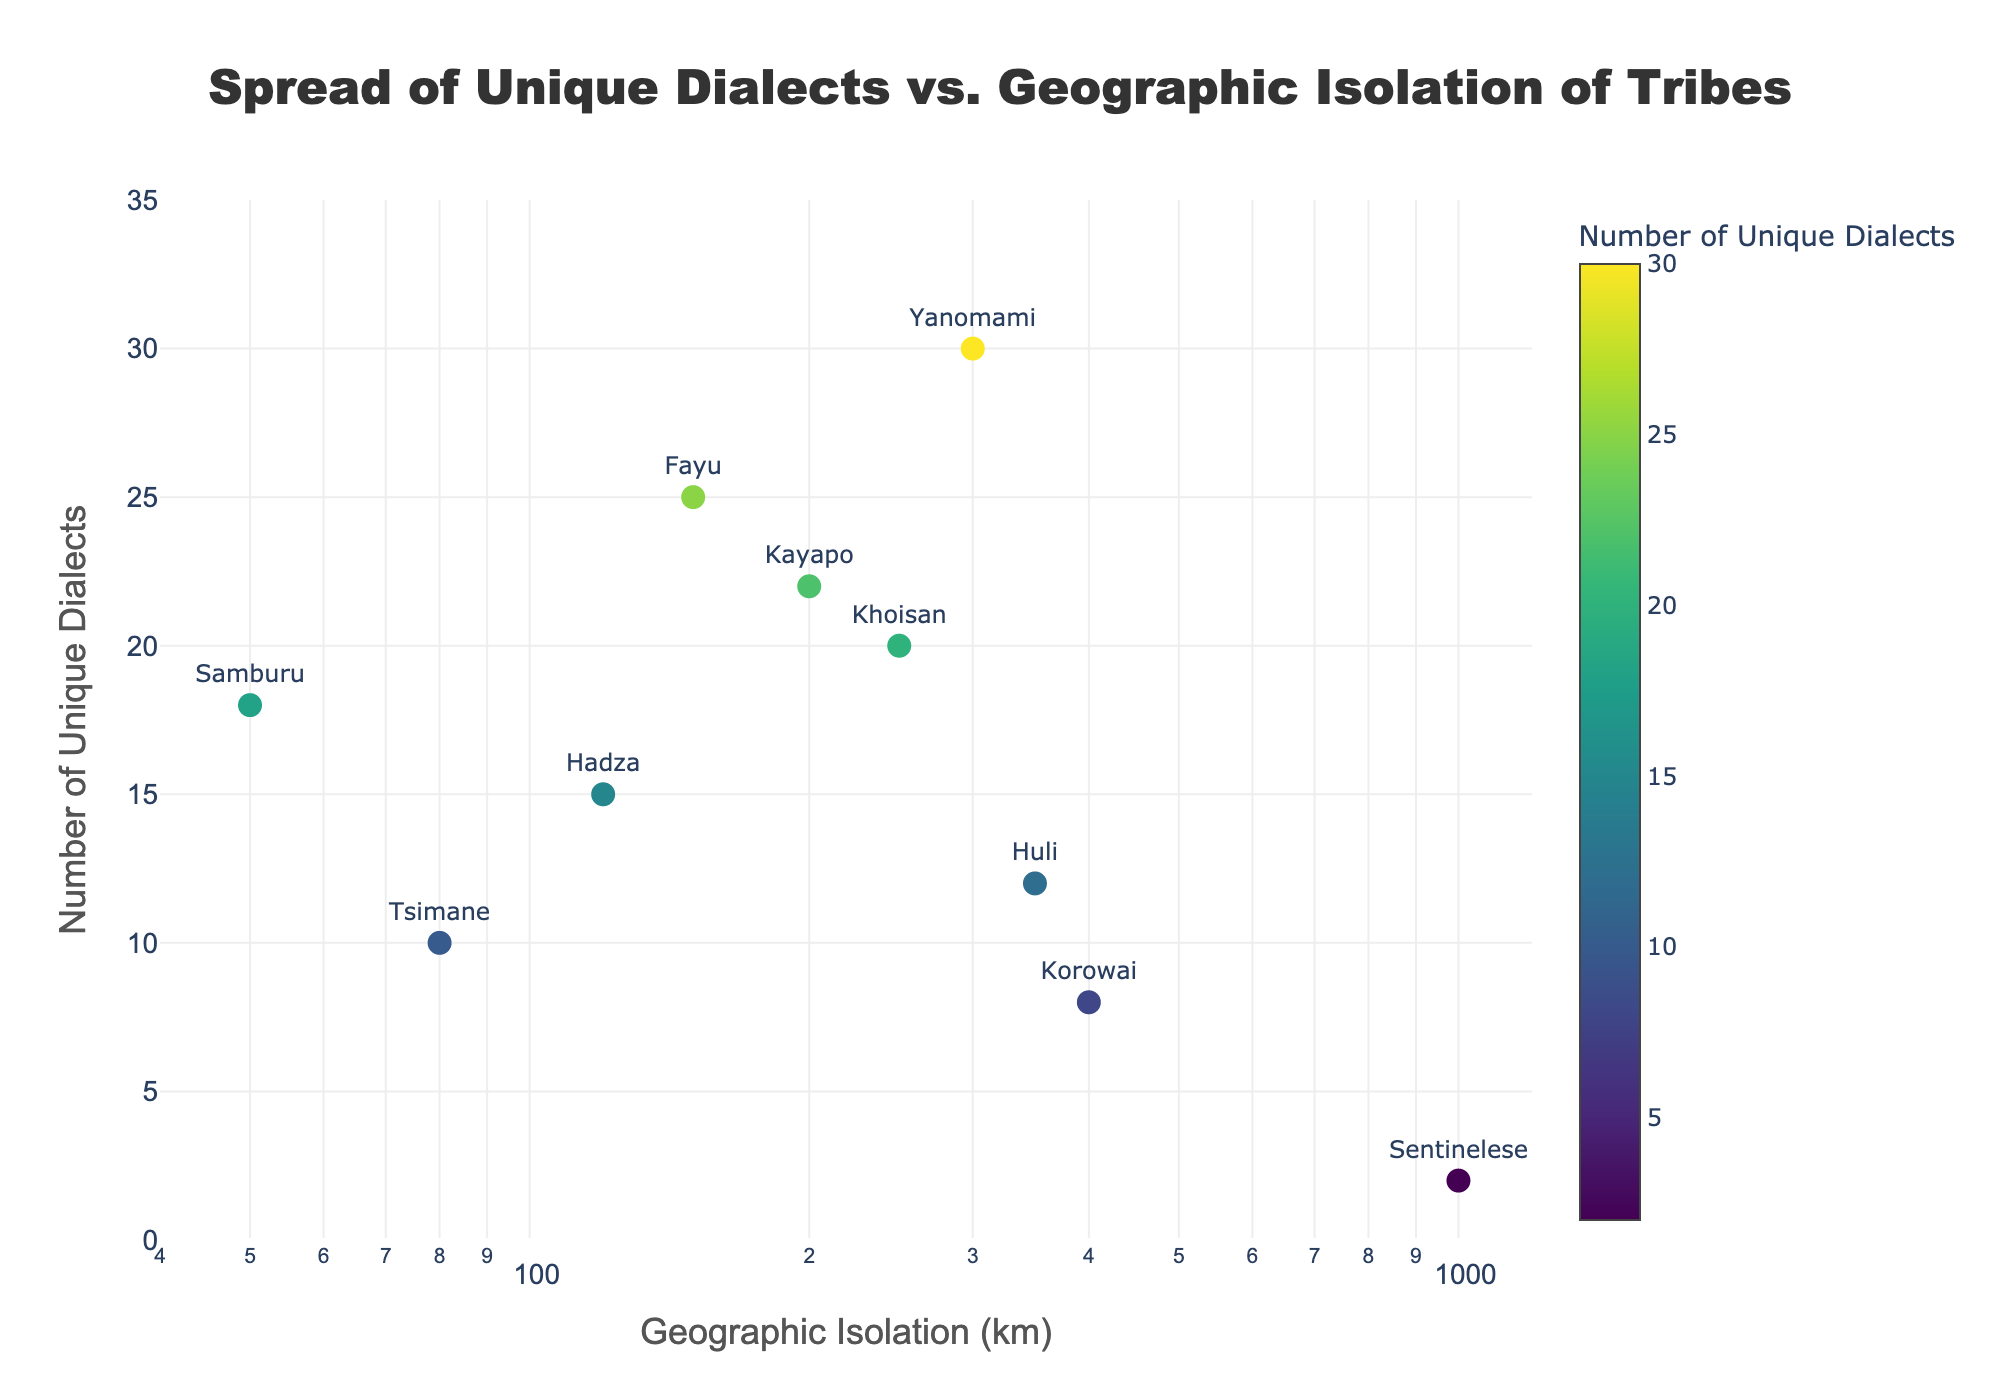What's the title of the figure? The title is located at the top center of the figure. It displays the overall subject of the data visualization.
Answer: Spread of Unique Dialects vs. Geographic Isolation of Tribes What are the axis titles in the figure? The axis titles are located adjacent to each axis. They indicate what the X and Y axes represent.
Answer: Geographic Isolation (km) and Number of Unique Dialects How many tribes have been plotted on the figure? There is one marker for each tribe represented in the scatter plot. Each marker also includes text labeling the tribe's name.
Answer: 10 Which tribe has the highest geographic isolation? By looking at the farthest point to the right on the X-axis (logarithmic scale), we can identify the tribe with the highest geographic isolation.
Answer: Sentinelese Which tribe has the highest number of unique dialects, and what is that number? Find the tribe whose marker is the highest on the Y-axis. The label next to the highest marker will indicate the tribe and the value.
Answer: Yanomami, 30 How does the number of unique dialects for the Huli tribe compare to that of the Korowai tribe? Locate the markers for Huli and Korowai, note their positions on the Y-axis, and compare the values.
Answer: Huli: 12, Korowai: 8 Which tribes have a geographic isolation less than 100 km? Find the markers on the scatter plot that are positioned left of the 100 km mark on the X-axis.
Answer: Tsimane and Samburu What is the average number of unique dialects for tribes with a geographic isolation greater than 300 km? Identify the tribes with geographic isolation over 300 km, sum their unique dialect values, and divide by the number of these tribes.
Answer: (Sentinelese: 2 + Yanomami: 30 + Korowai: 8 + Huli: 12) / 4 = 13 What trend can be observed between geographic isolation and the number of unique dialects? Observe the overall direction and pattern of the data points on the scatter plot. The trend will reflect the general relationship between the two variables.
Answer: No clear trend Which tribes have a significantly higher number of unique dialects compared to their geographic isolation? Look for tribes positioned relatively high on the Y-axis but not too far along the X-axis, indicating a high number of unique dialects despite lower geographic isolation.
Answer: Yanomami, Fayu, Kayapo 